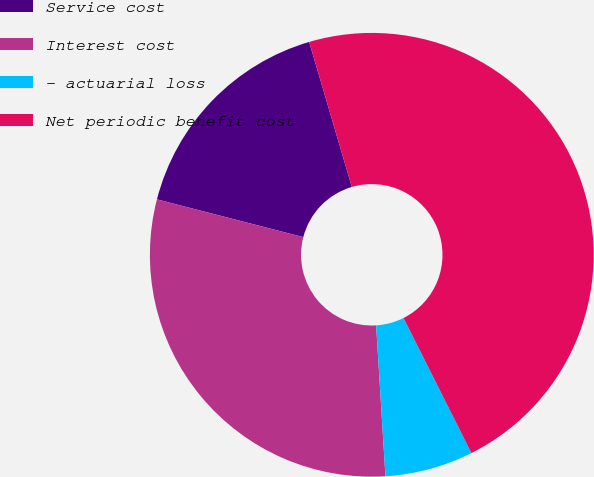<chart> <loc_0><loc_0><loc_500><loc_500><pie_chart><fcel>Service cost<fcel>Interest cost<fcel>- actuarial loss<fcel>Net periodic benefit cost<nl><fcel>16.43%<fcel>30.0%<fcel>6.43%<fcel>47.14%<nl></chart> 